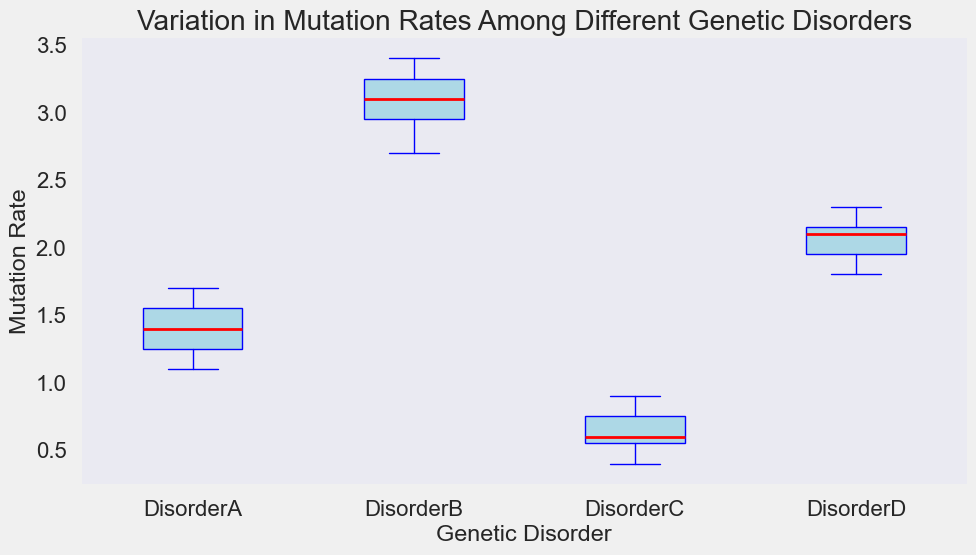What is the median mutation rate for Disorder A? The median is the middle value of the ordered data points. The mutation rates for Disorder A are 1.1, 1.2, 1.3, 1.4, 1.5, 1.6, 1.7, so the median is 1.4.
Answer: 1.4 Which disorder has the highest median mutation rate? To find this, look at the median lines for each box plot. The median mutation rates for the disorders are Disorder A (1.4), Disorder B (3.1), Disorder C (0.6), and Disorder D (2.1). Disorder B has the highest median mutation rate.
Answer: Disorder B Which disorder shows the most variation in mutation rates? The range of the box plots, indicated by the length of the boxes and the whiskers, shows the variation. Disorder B shows the largest range, indicating the most variation.
Answer: Disorder B Which disorder has the lowest upper quartile value? The upper quartile is the top edge of the box. Comparing the boxes, we see that Disorder C has the lowest upper quartile value.
Answer: Disorder C What is the range of mutation rates for Disorder D? The range is the difference between the maximum and minimum values. For Disorder D, the minimum value is 1.8, and the maximum value is 2.3, so the range is 2.3 - 1.8 = 0.5.
Answer: 0.5 Compare the interquartile ranges (IQRs) of Disorder A and Disorder B. Which one is larger? The IQR is the difference between the upper quartile (75th percentile) and the lower quartile (25th percentile) of the box. Disorder A has an IQR from 1.3 to 1.6 (1.6 - 1.3 = 0.3), and Disorder B has an IQR from 2.9 to 3.3 (3.3 - 2.9 = 0.4). Disorder B has a larger IQR.
Answer: Disorder B 